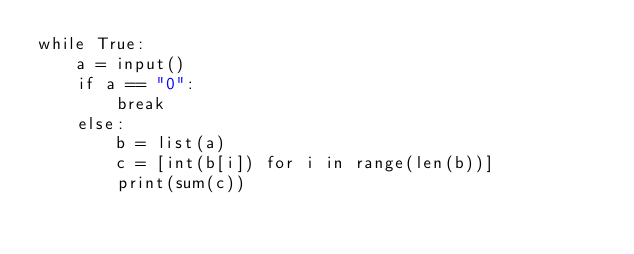<code> <loc_0><loc_0><loc_500><loc_500><_Python_>while True:
    a = input()
    if a == "0":
        break
    else:
        b = list(a)
        c = [int(b[i]) for i in range(len(b))]
        print(sum(c))    </code> 